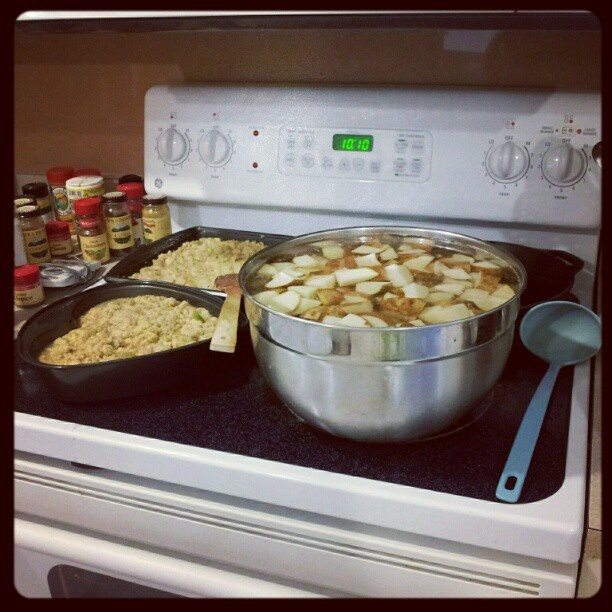Describe the objects in this image and their specific colors. I can see oven in black, darkgray, lightgray, and gray tones, bowl in black, darkgray, tan, and gray tones, spoon in black, gray, and purple tones, bottle in black, maroon, and olive tones, and spoon in black, tan, and gray tones in this image. 